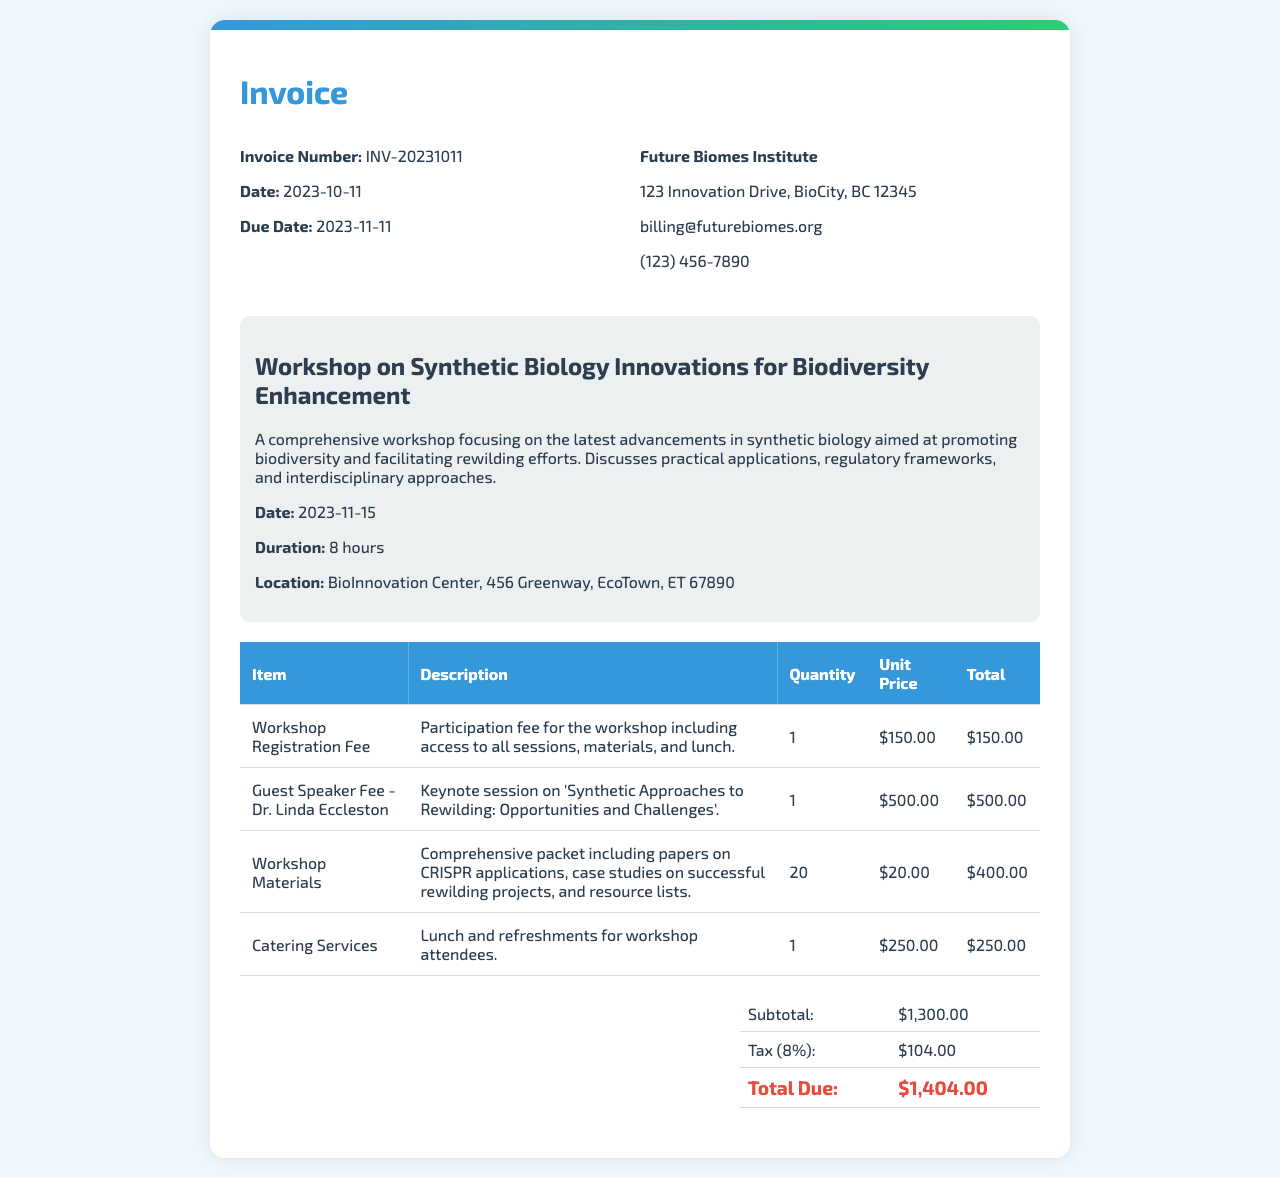What is the invoice number? The invoice number is specified in the invoice details section which is INV-20231011.
Answer: INV-20231011 What is the date of the workshop? The date of the workshop is detailed in the workshop section as November 15, 2023.
Answer: 2023-11-15 Who is the guest speaker? The guest speaker is mentioned in the item description as Dr. Linda Eccleston.
Answer: Dr. Linda Eccleston What is the total due amount? The total due amount is calculated at the bottom of the invoice, which is $1,404.00.
Answer: $1,404.00 How many hours is the workshop scheduled for? The duration of the workshop is stated in the workshop details as 8 hours.
Answer: 8 hours What is included in the workshop materials? The materials are described as including papers on CRISPR applications, case studies on successful rewilding projects, and resource lists.
Answer: Comprehensive packet What is the tax percentage applied to the subtotal? The tax percentage is listed in the financial breakdown section as 8%.
Answer: 8% What is the address of the Future Biomes Institute? The address is provided in the billing information as 123 Innovation Drive, BioCity, BC 12345.
Answer: 123 Innovation Drive, BioCity, BC 12345 What is the primary focus of the workshop? The primary focus is detailed in the workshop description as advancements in synthetic biology aimed at promoting biodiversity.
Answer: Enhancing biodiversity 